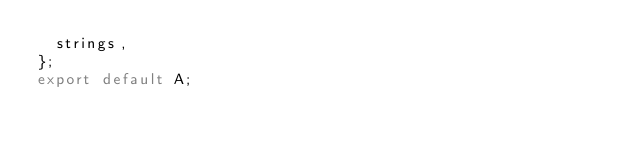Convert code to text. <code><loc_0><loc_0><loc_500><loc_500><_TypeScript_>  strings,
};
export default A;
</code> 